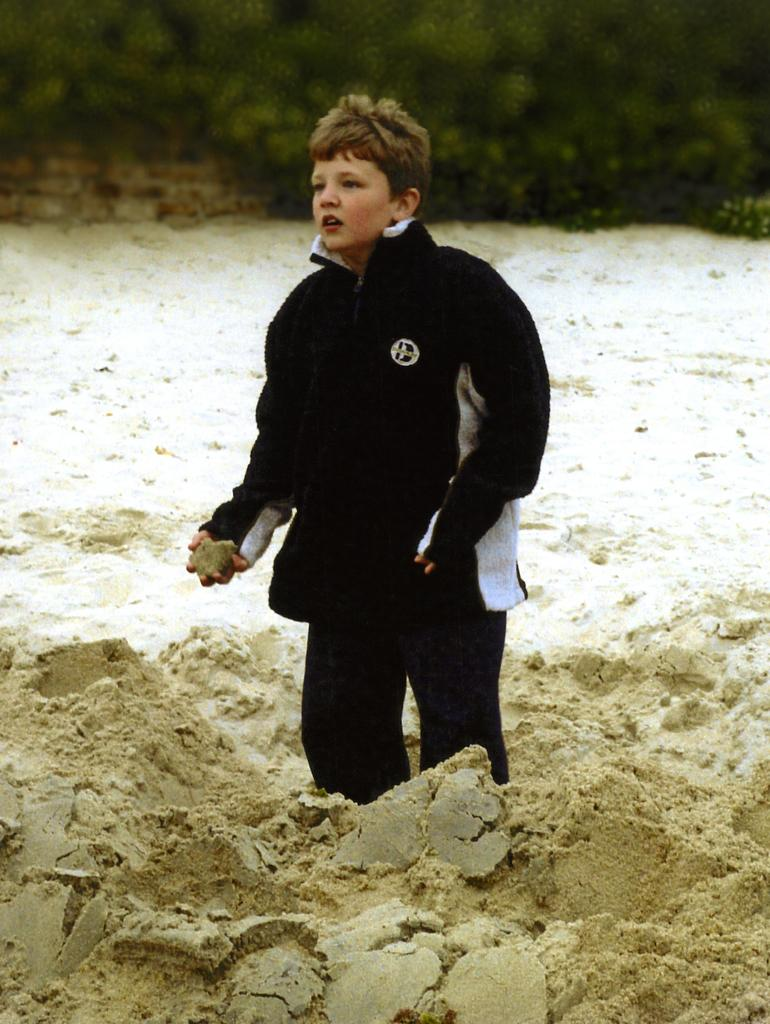What is the main subject of the image? There is a boy standing in the image. What is the boy wearing? The boy is wearing clothes. What is the boy holding in his hand? The boy is holding mud in his hand. Can you describe the background of the image? The background of the image is blurred. What type of wrench is the boy using to sort the mud in the image? There is no wrench or sorting activity present in the image; the boy is simply holding mud in his hand. 